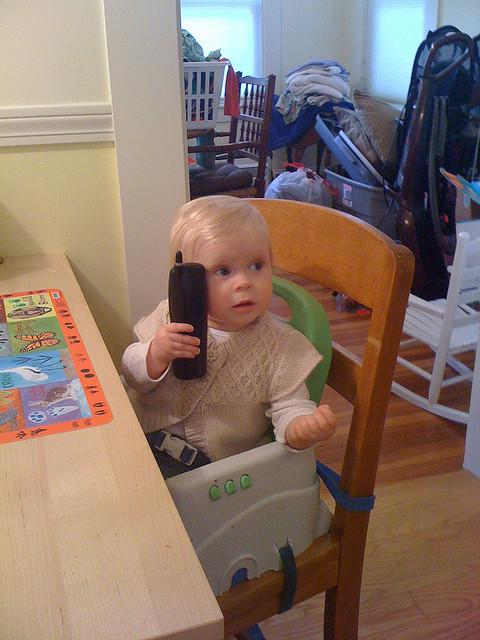Whos number did the child dial?

Choices:
A) no ones
B) mom
C) dad
D) her own no ones 